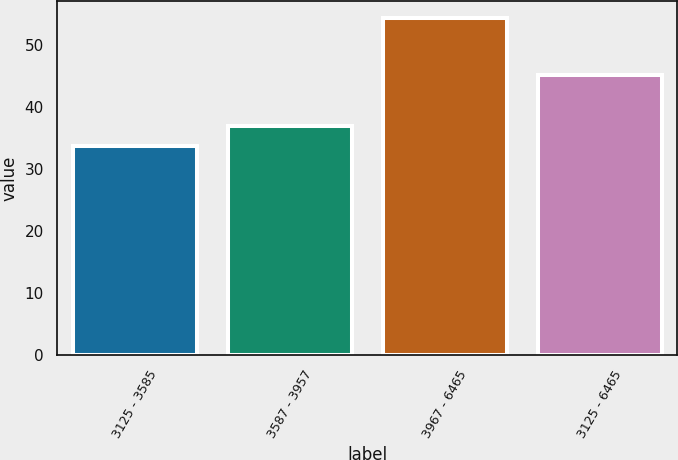<chart> <loc_0><loc_0><loc_500><loc_500><bar_chart><fcel>3125 - 3585<fcel>3587 - 3957<fcel>3967 - 6465<fcel>3125 - 6465<nl><fcel>33.76<fcel>36.97<fcel>54.36<fcel>45.13<nl></chart> 